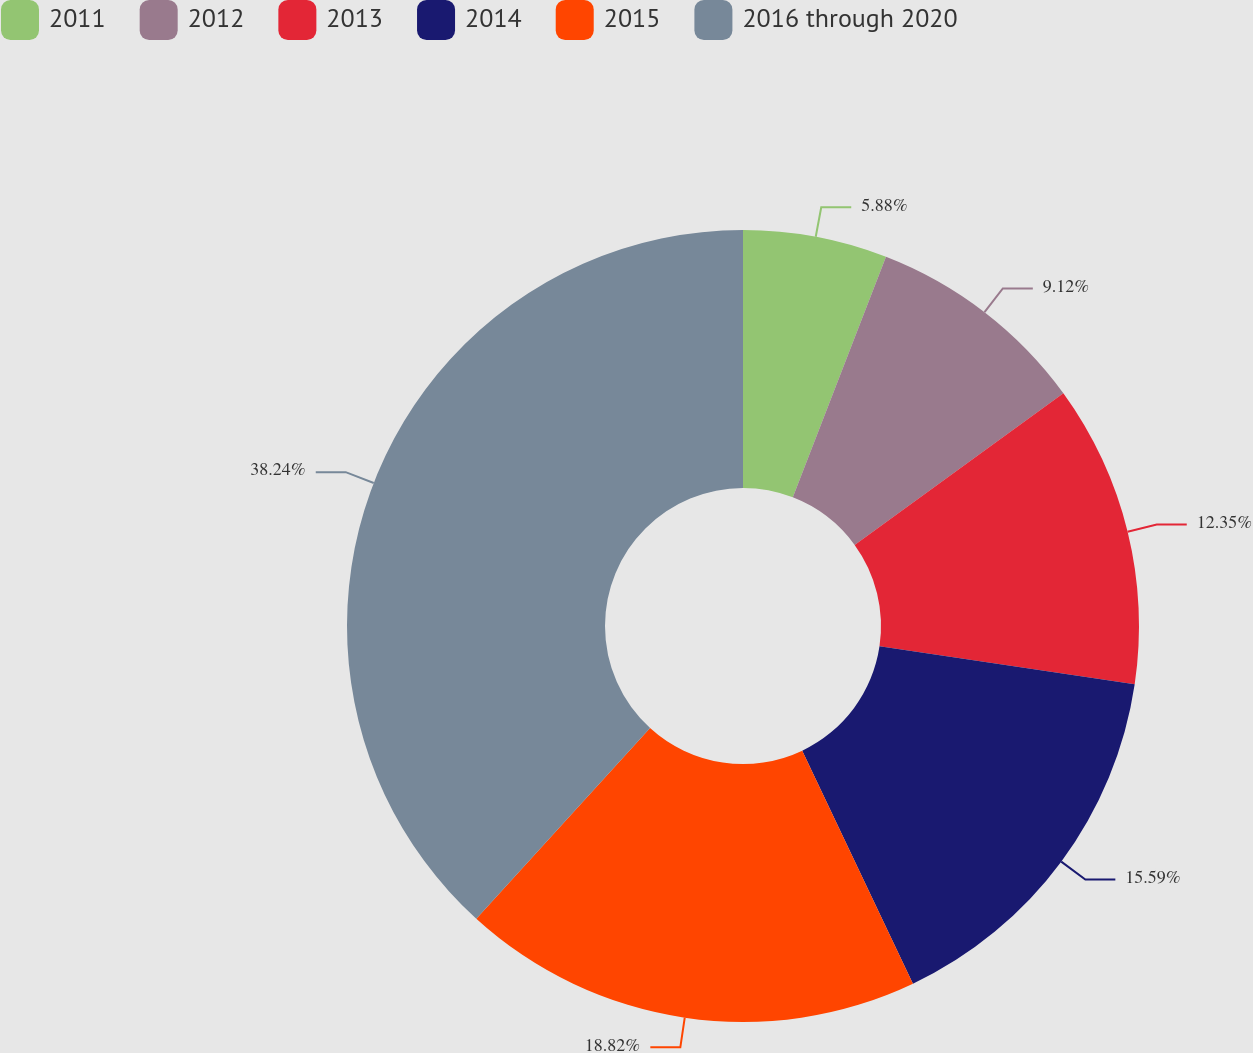Convert chart. <chart><loc_0><loc_0><loc_500><loc_500><pie_chart><fcel>2011<fcel>2012<fcel>2013<fcel>2014<fcel>2015<fcel>2016 through 2020<nl><fcel>5.88%<fcel>9.12%<fcel>12.35%<fcel>15.59%<fcel>18.82%<fcel>38.24%<nl></chart> 